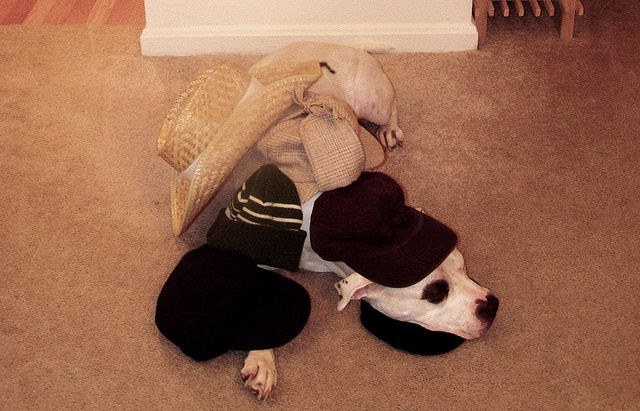Describe the objects in this image and their specific colors. I can see a dog in salmon, tan, gray, and black tones in this image. 